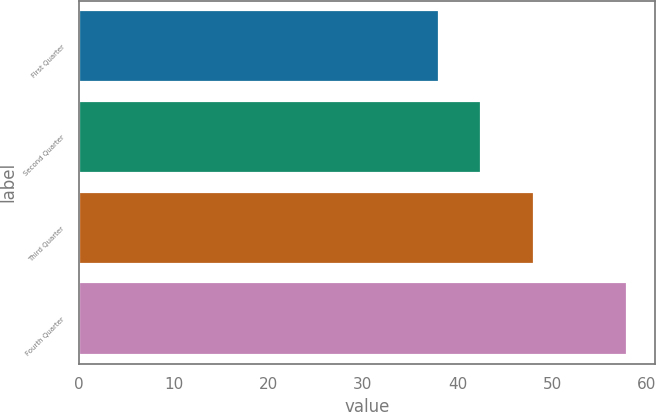Convert chart. <chart><loc_0><loc_0><loc_500><loc_500><bar_chart><fcel>First Quarter<fcel>Second Quarter<fcel>Third Quarter<fcel>Fourth Quarter<nl><fcel>38.02<fcel>42.52<fcel>48.09<fcel>57.92<nl></chart> 